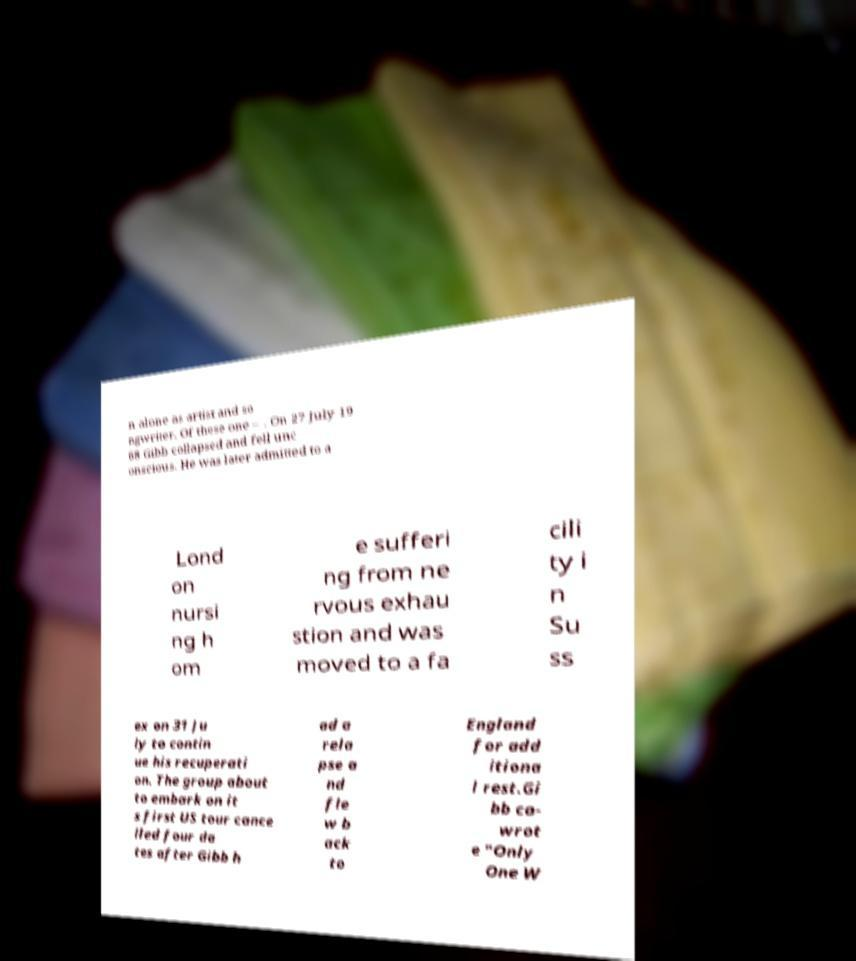Could you extract and type out the text from this image? n alone as artist and so ngwriter. Of these one – . On 27 July 19 68 Gibb collapsed and fell unc onscious. He was later admitted to a Lond on nursi ng h om e sufferi ng from ne rvous exhau stion and was moved to a fa cili ty i n Su ss ex on 31 Ju ly to contin ue his recuperati on. The group about to embark on it s first US tour cance lled four da tes after Gibb h ad a rela pse a nd fle w b ack to England for add itiona l rest.Gi bb co- wrot e "Only One W 